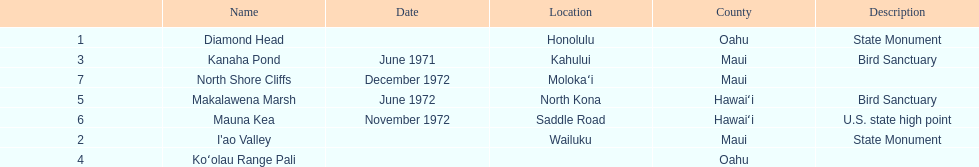How many images are listed? 6. 